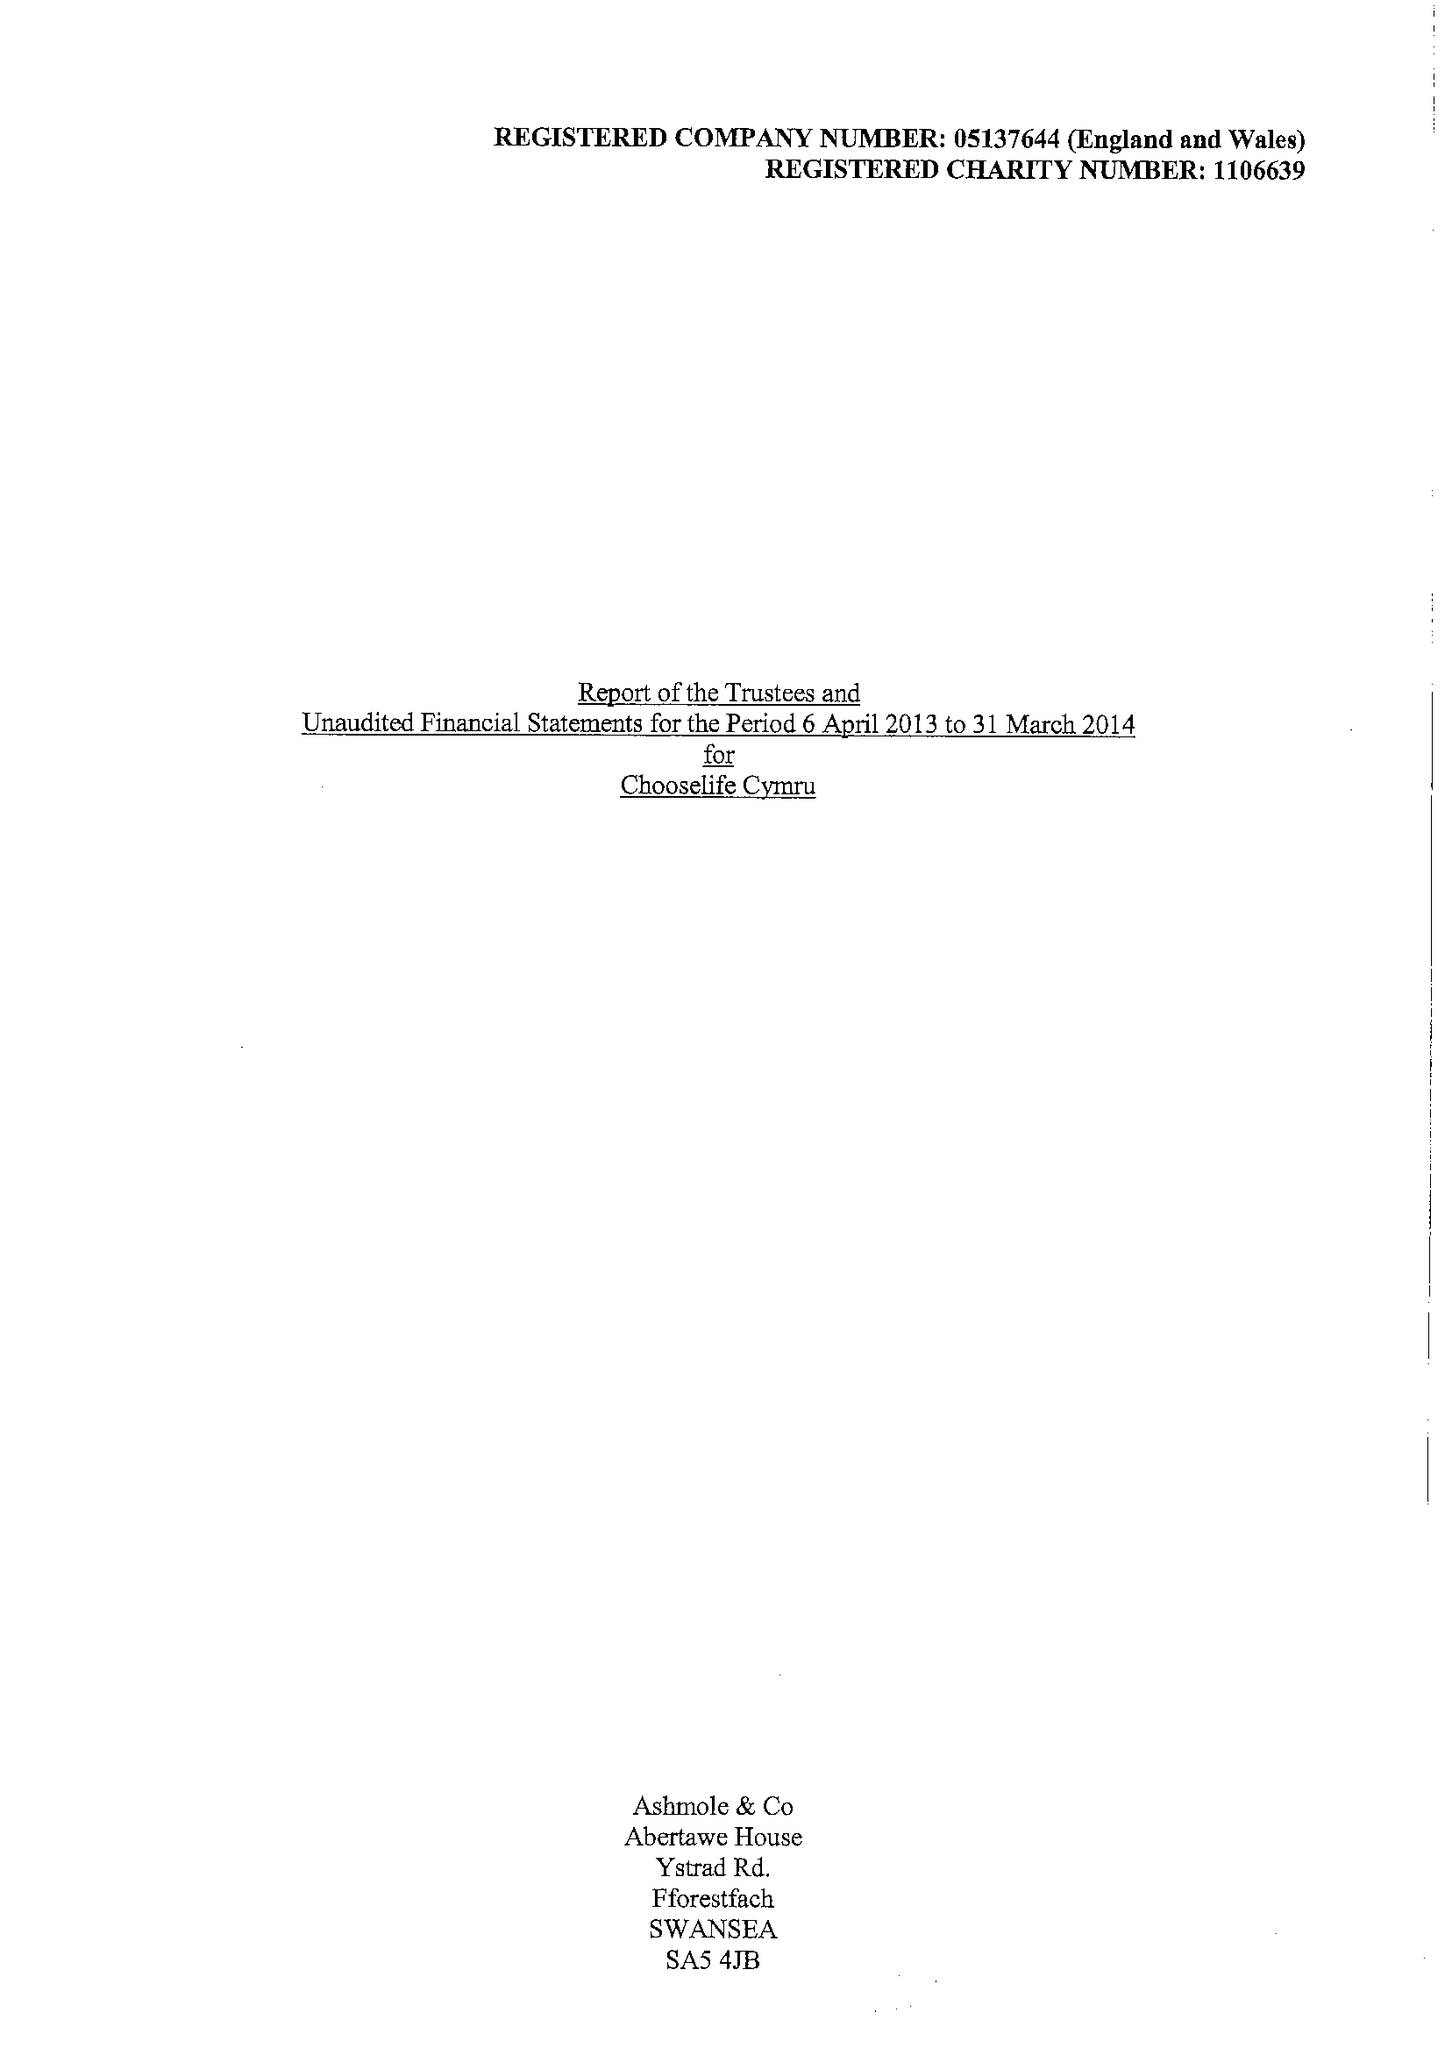What is the value for the charity_name?
Answer the question using a single word or phrase. Chooselife Cymru 